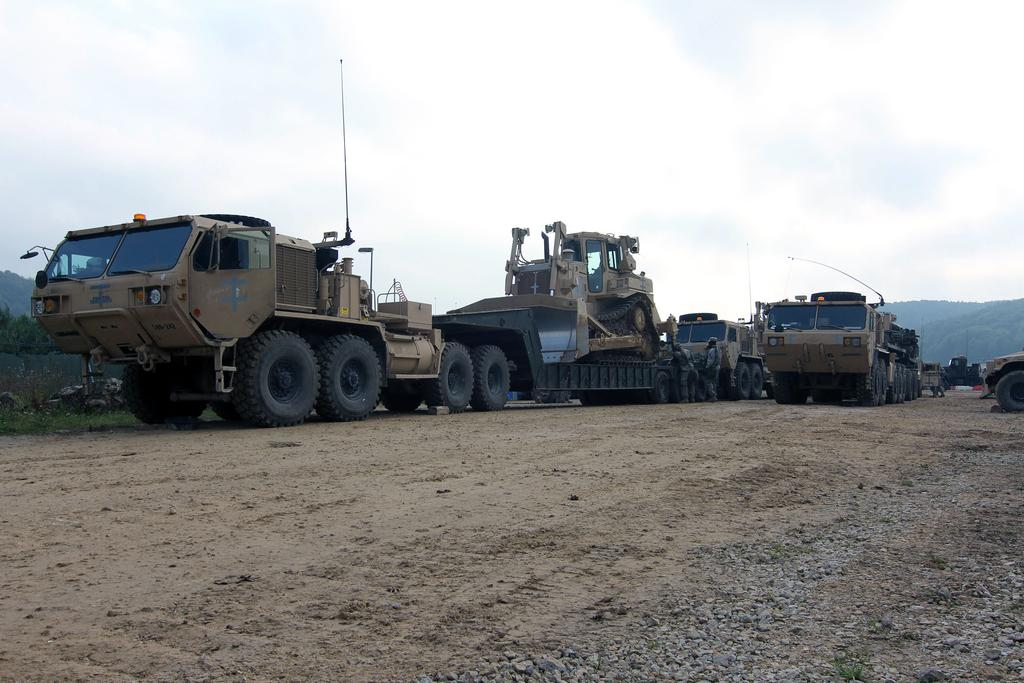What vehicles are present on the ground level in the image? There are trucks on the ground in the image. What part of the natural environment is visible in the image? The sky is visible in the image. What is the weather like in the image? The sky is cloudy in the image. What type of popcorn is being served at the plantation in the image? There is no popcorn or plantation present in the image; it features trucks on the ground and a cloudy sky. 